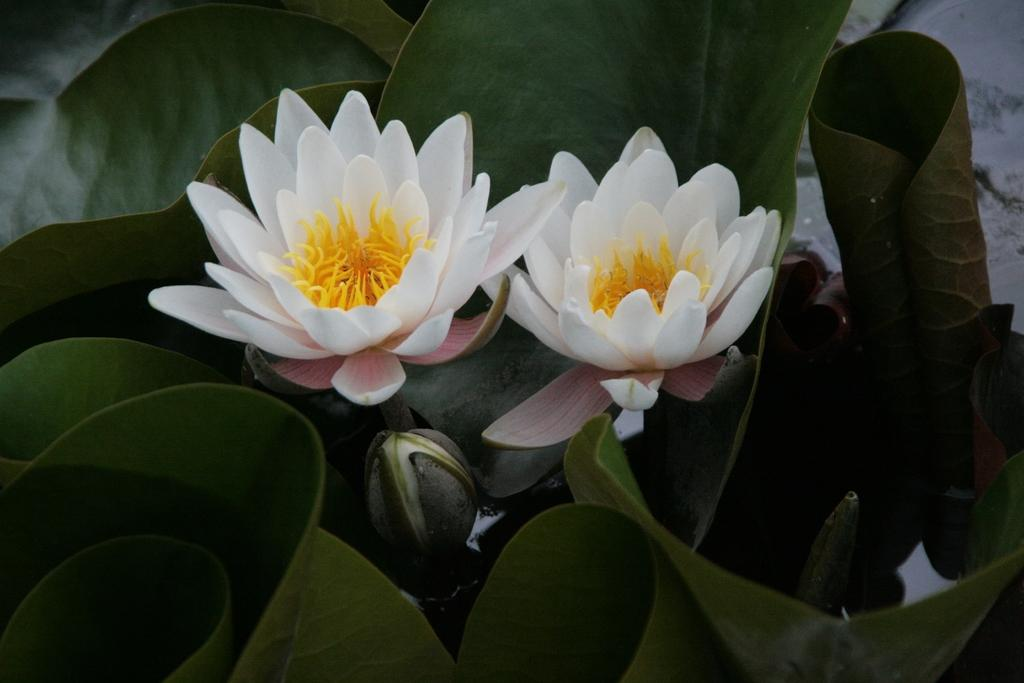What type of living organisms can be seen in the image? There are flowers in the image. Where are the flowers located? The flowers are on plants. What colors are the flowers in the image? The flowers are in white and yellow colors. Can you see a rifle hidden among the flowers in the image? There is no rifle present in the image; it only features flowers on plants in white and yellow colors. 